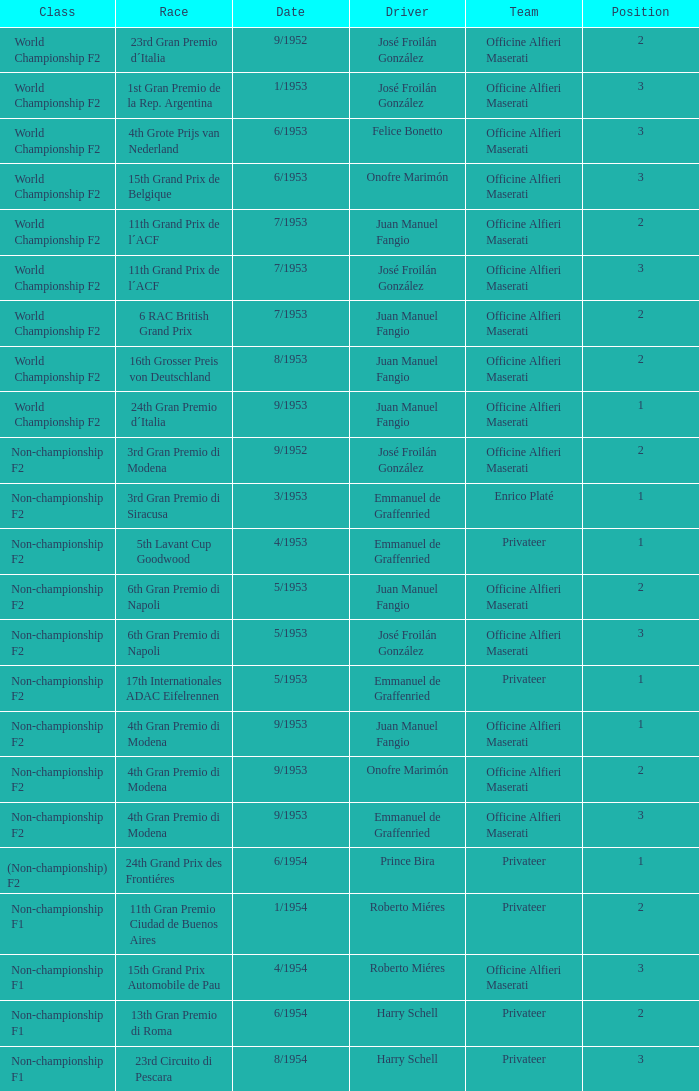What class has the date of 8/1954? Non-championship F1. 